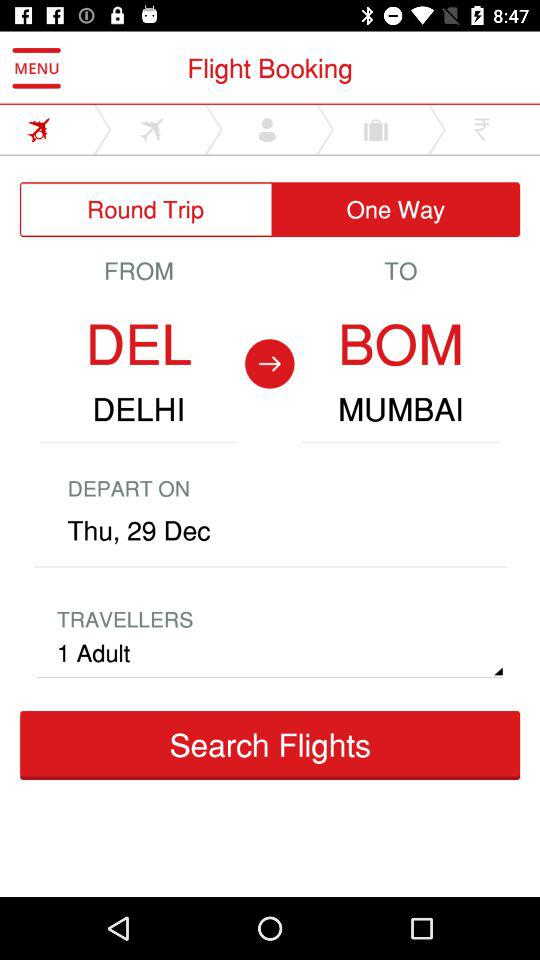What is the destination city of the flight? The destination city of the flight is Mumbai. 